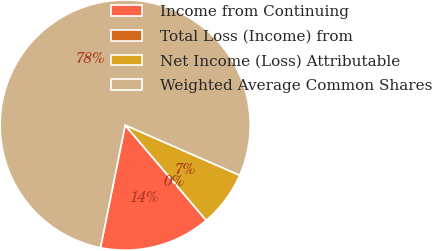Convert chart to OTSL. <chart><loc_0><loc_0><loc_500><loc_500><pie_chart><fcel>Income from Continuing<fcel>Total Loss (Income) from<fcel>Net Income (Loss) Attributable<fcel>Weighted Average Common Shares<nl><fcel>14.39%<fcel>0.0%<fcel>7.2%<fcel>78.41%<nl></chart> 